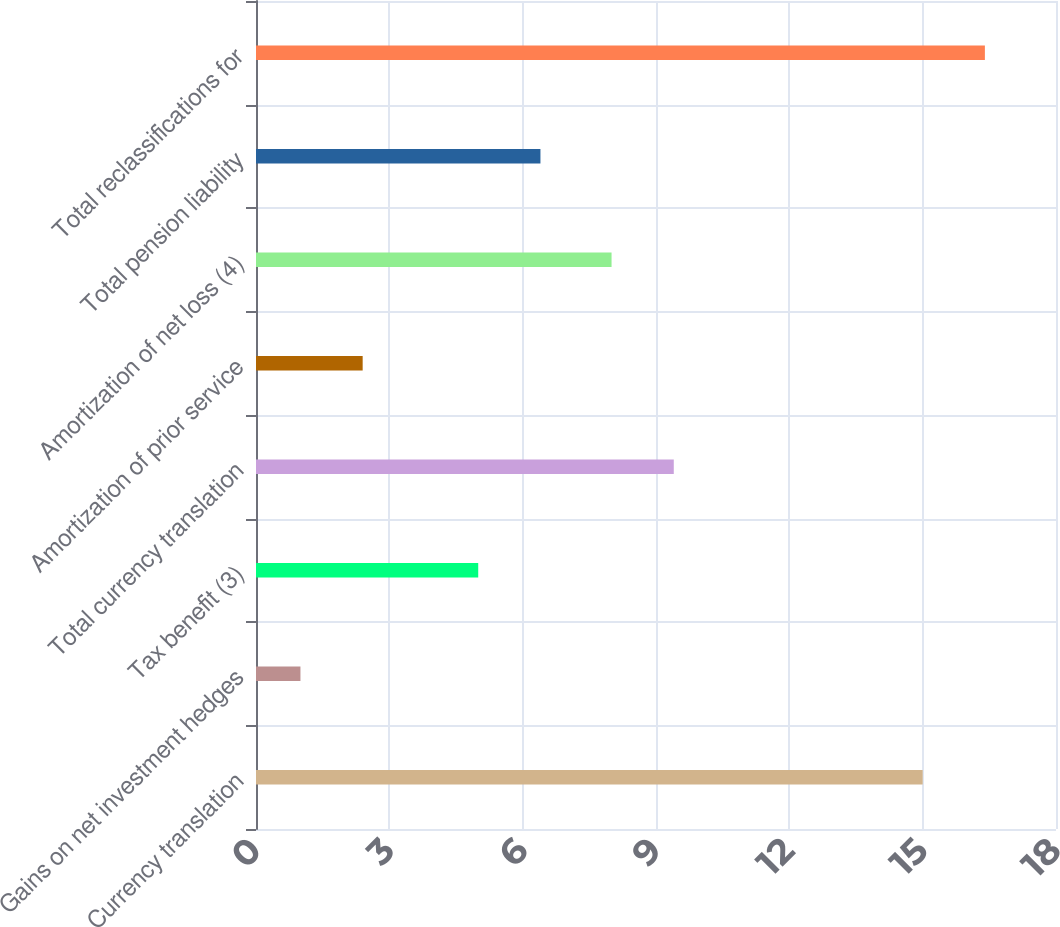Convert chart. <chart><loc_0><loc_0><loc_500><loc_500><bar_chart><fcel>Currency translation<fcel>Gains on net investment hedges<fcel>Tax benefit (3)<fcel>Total currency translation<fcel>Amortization of prior service<fcel>Amortization of net loss (4)<fcel>Total pension liability<fcel>Total reclassifications for<nl><fcel>15<fcel>1<fcel>5<fcel>9.4<fcel>2.4<fcel>8<fcel>6.4<fcel>16.4<nl></chart> 